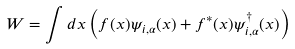Convert formula to latex. <formula><loc_0><loc_0><loc_500><loc_500>W = \int d x \left ( f ( x ) \psi _ { i , \alpha } ( x ) + f ^ { * } ( x ) \psi ^ { \dag } _ { i , \alpha } ( x ) \right )</formula> 